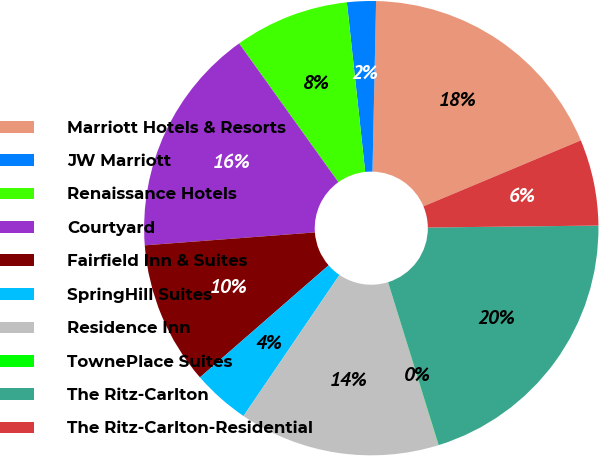Convert chart to OTSL. <chart><loc_0><loc_0><loc_500><loc_500><pie_chart><fcel>Marriott Hotels & Resorts<fcel>JW Marriott<fcel>Renaissance Hotels<fcel>Courtyard<fcel>Fairfield Inn & Suites<fcel>SpringHill Suites<fcel>Residence Inn<fcel>TownePlace Suites<fcel>The Ritz-Carlton<fcel>The Ritz-Carlton-Residential<nl><fcel>18.35%<fcel>2.05%<fcel>8.17%<fcel>16.32%<fcel>10.2%<fcel>4.09%<fcel>14.28%<fcel>0.02%<fcel>20.39%<fcel>6.13%<nl></chart> 